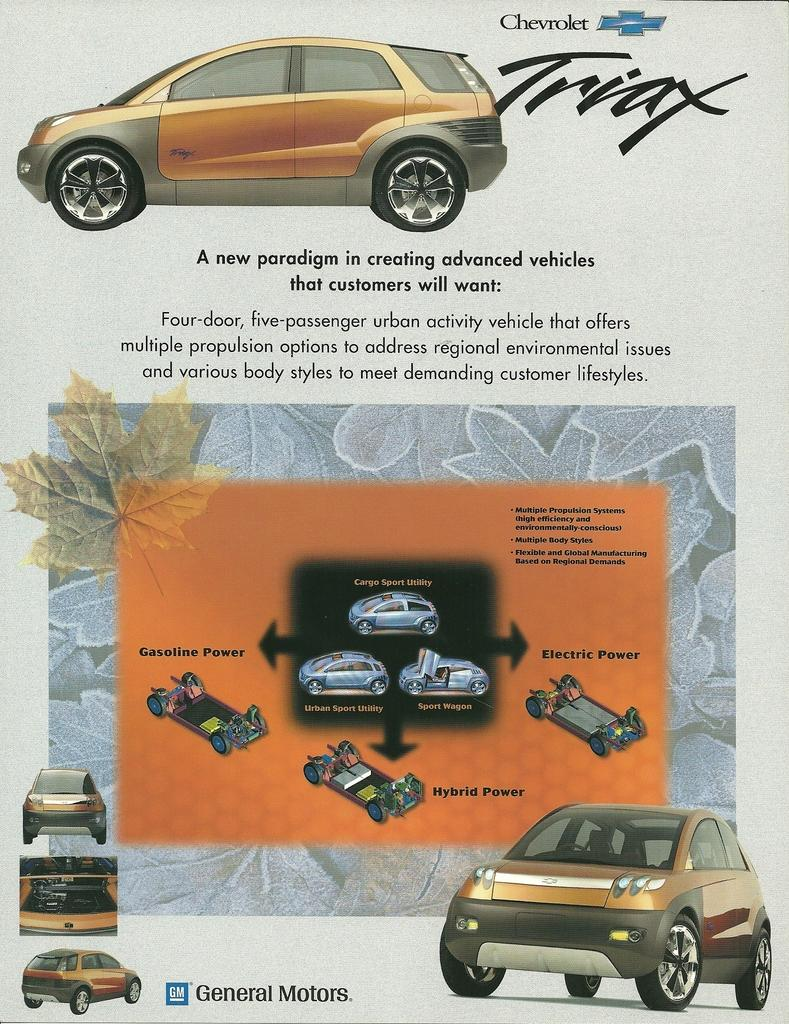What type of pictures are present in the image? There are animated pictures of cars in the image. What else can be found in the image besides the animated pictures? There is text written on the image. What type of dress is the actor wearing in the image? There is no actor or dress present in the image; it features animated pictures of cars and text. 